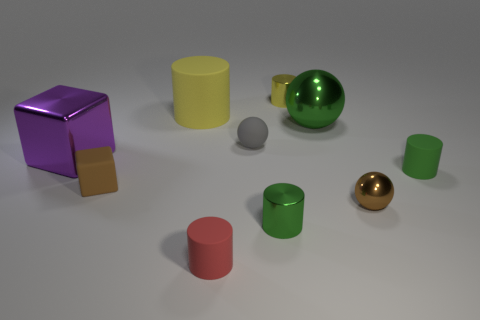Subtract all tiny shiny cylinders. How many cylinders are left? 3 Subtract 2 cylinders. How many cylinders are left? 3 Subtract all cubes. How many objects are left? 8 Subtract all yellow balls. How many yellow cylinders are left? 2 Subtract 1 green balls. How many objects are left? 9 Subtract all gray cylinders. Subtract all gray cubes. How many cylinders are left? 5 Subtract all large green metallic spheres. Subtract all large yellow cylinders. How many objects are left? 8 Add 4 red matte objects. How many red matte objects are left? 5 Add 5 small yellow objects. How many small yellow objects exist? 6 Subtract all brown cubes. How many cubes are left? 1 